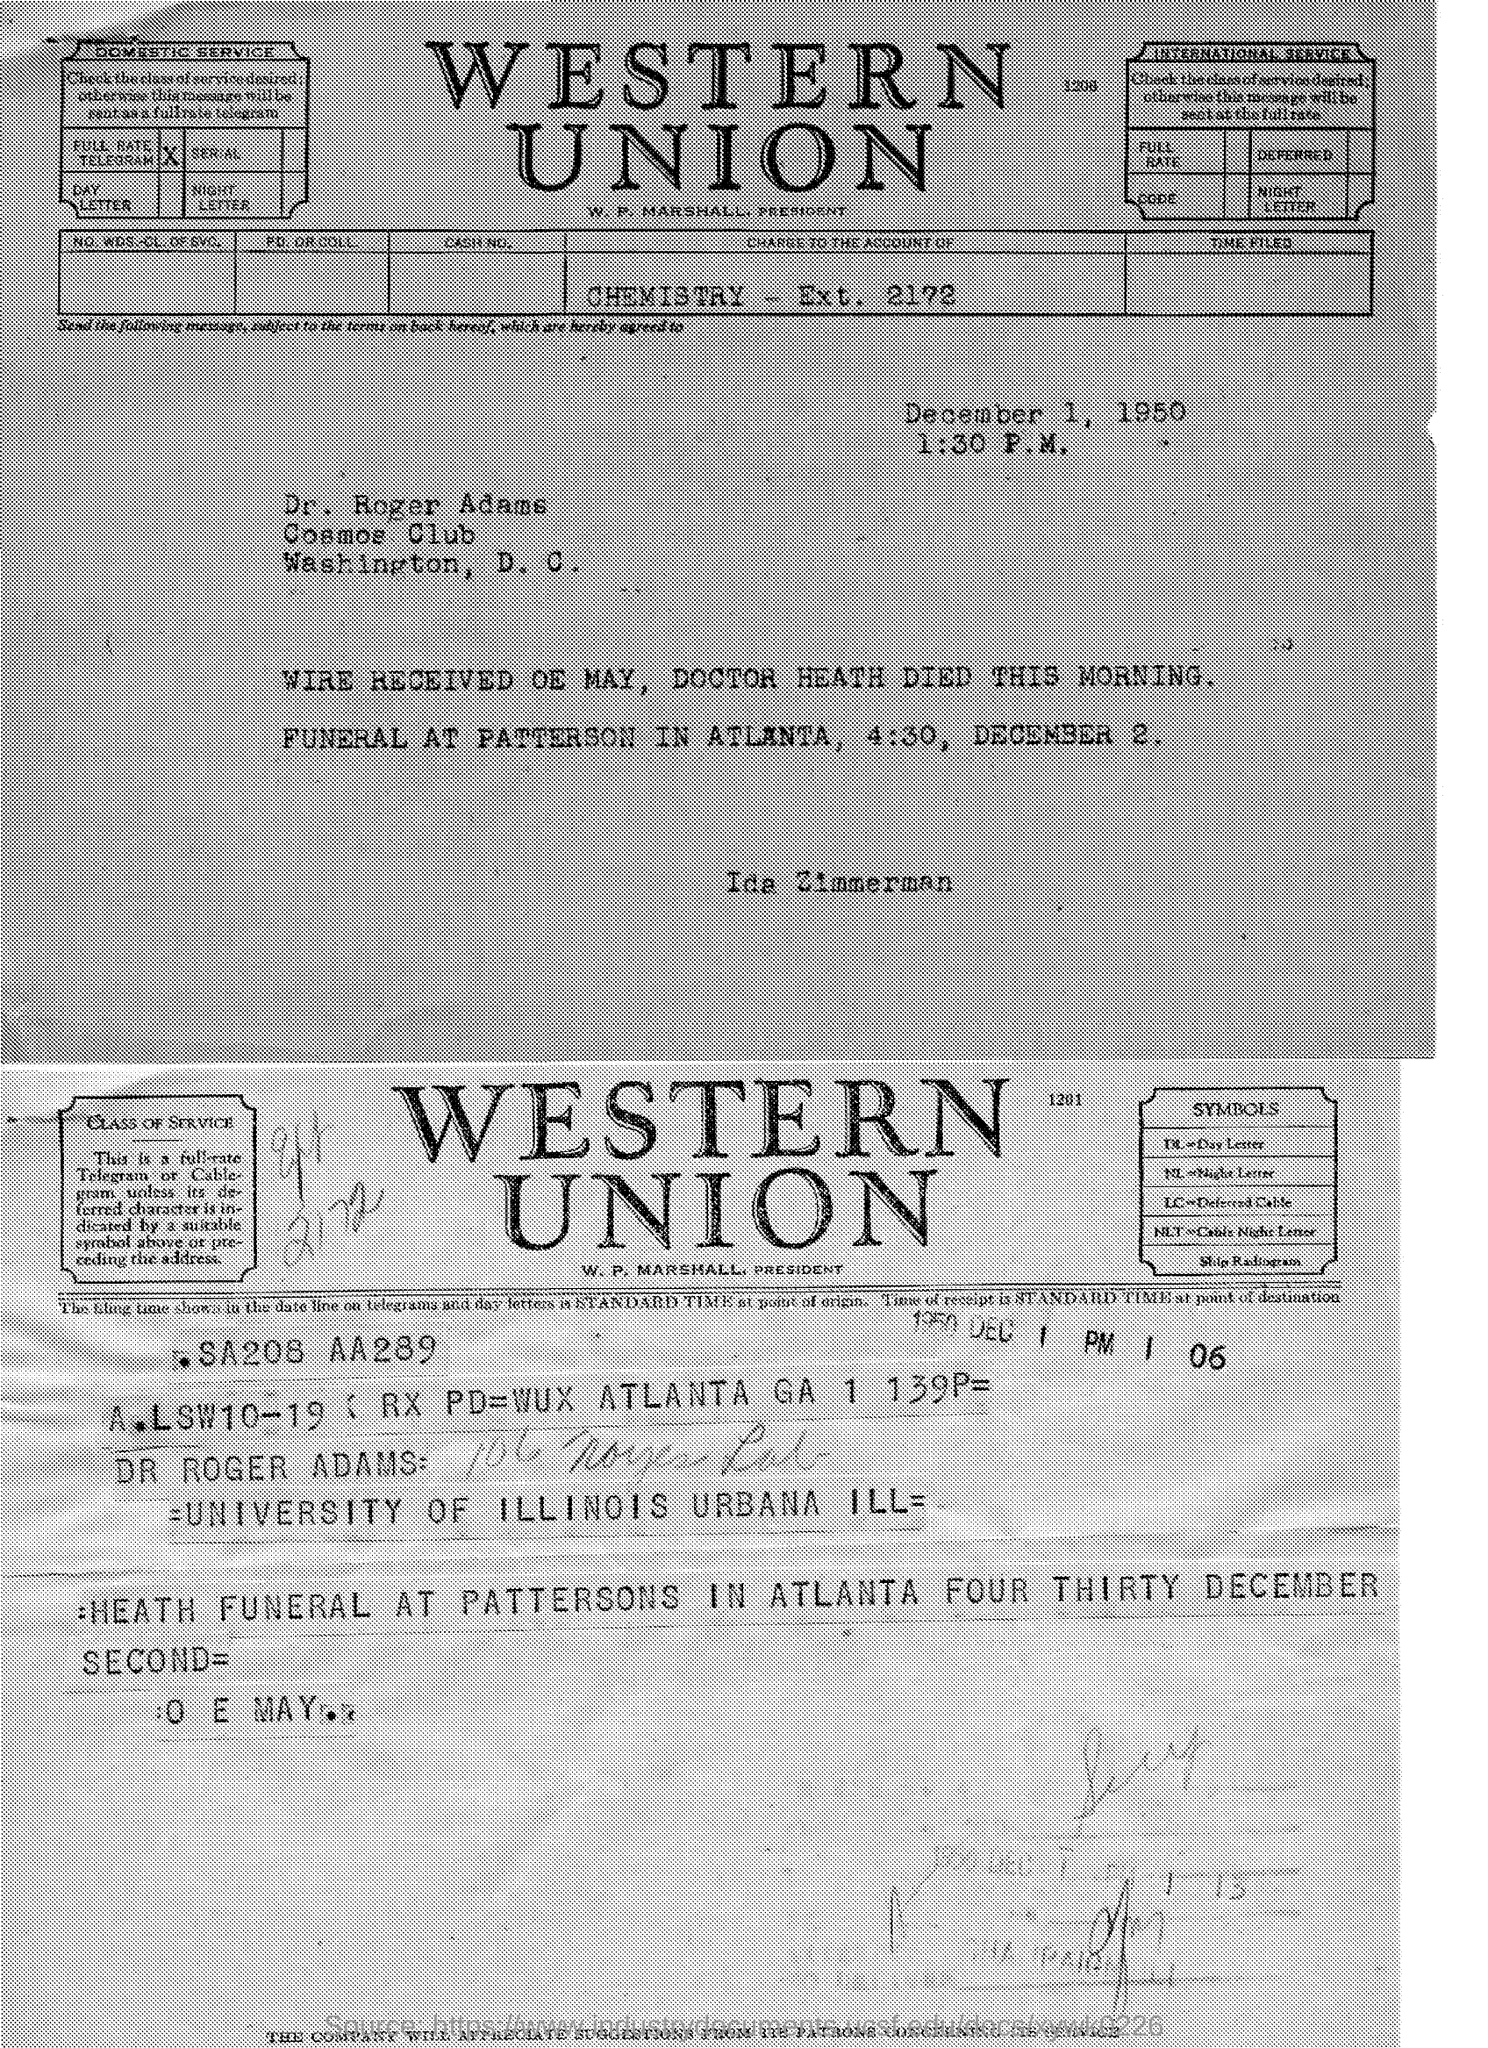What is the date of the funeral mentioned in the given page ?
Give a very brief answer. December Second. At what time funeral is scheduled ?
Your response must be concise. 4:30. 